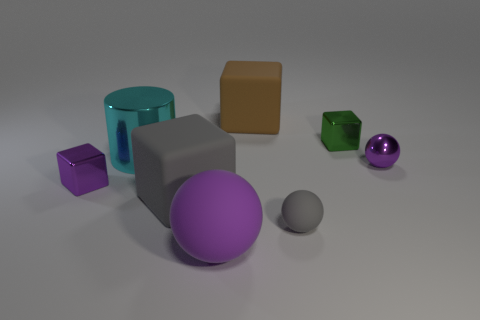Considering this assortment of objects, what sort of environment or setting do you imagine this could represent? This scene could represent a study on shapes and materials in a controlled environment, like a 3D rendering test or an artist's conceptual layout. The deliberate placement and variety suggest a focus on form and color interaction, perhaps as part of a visual art project or an educational tool for geometry. 